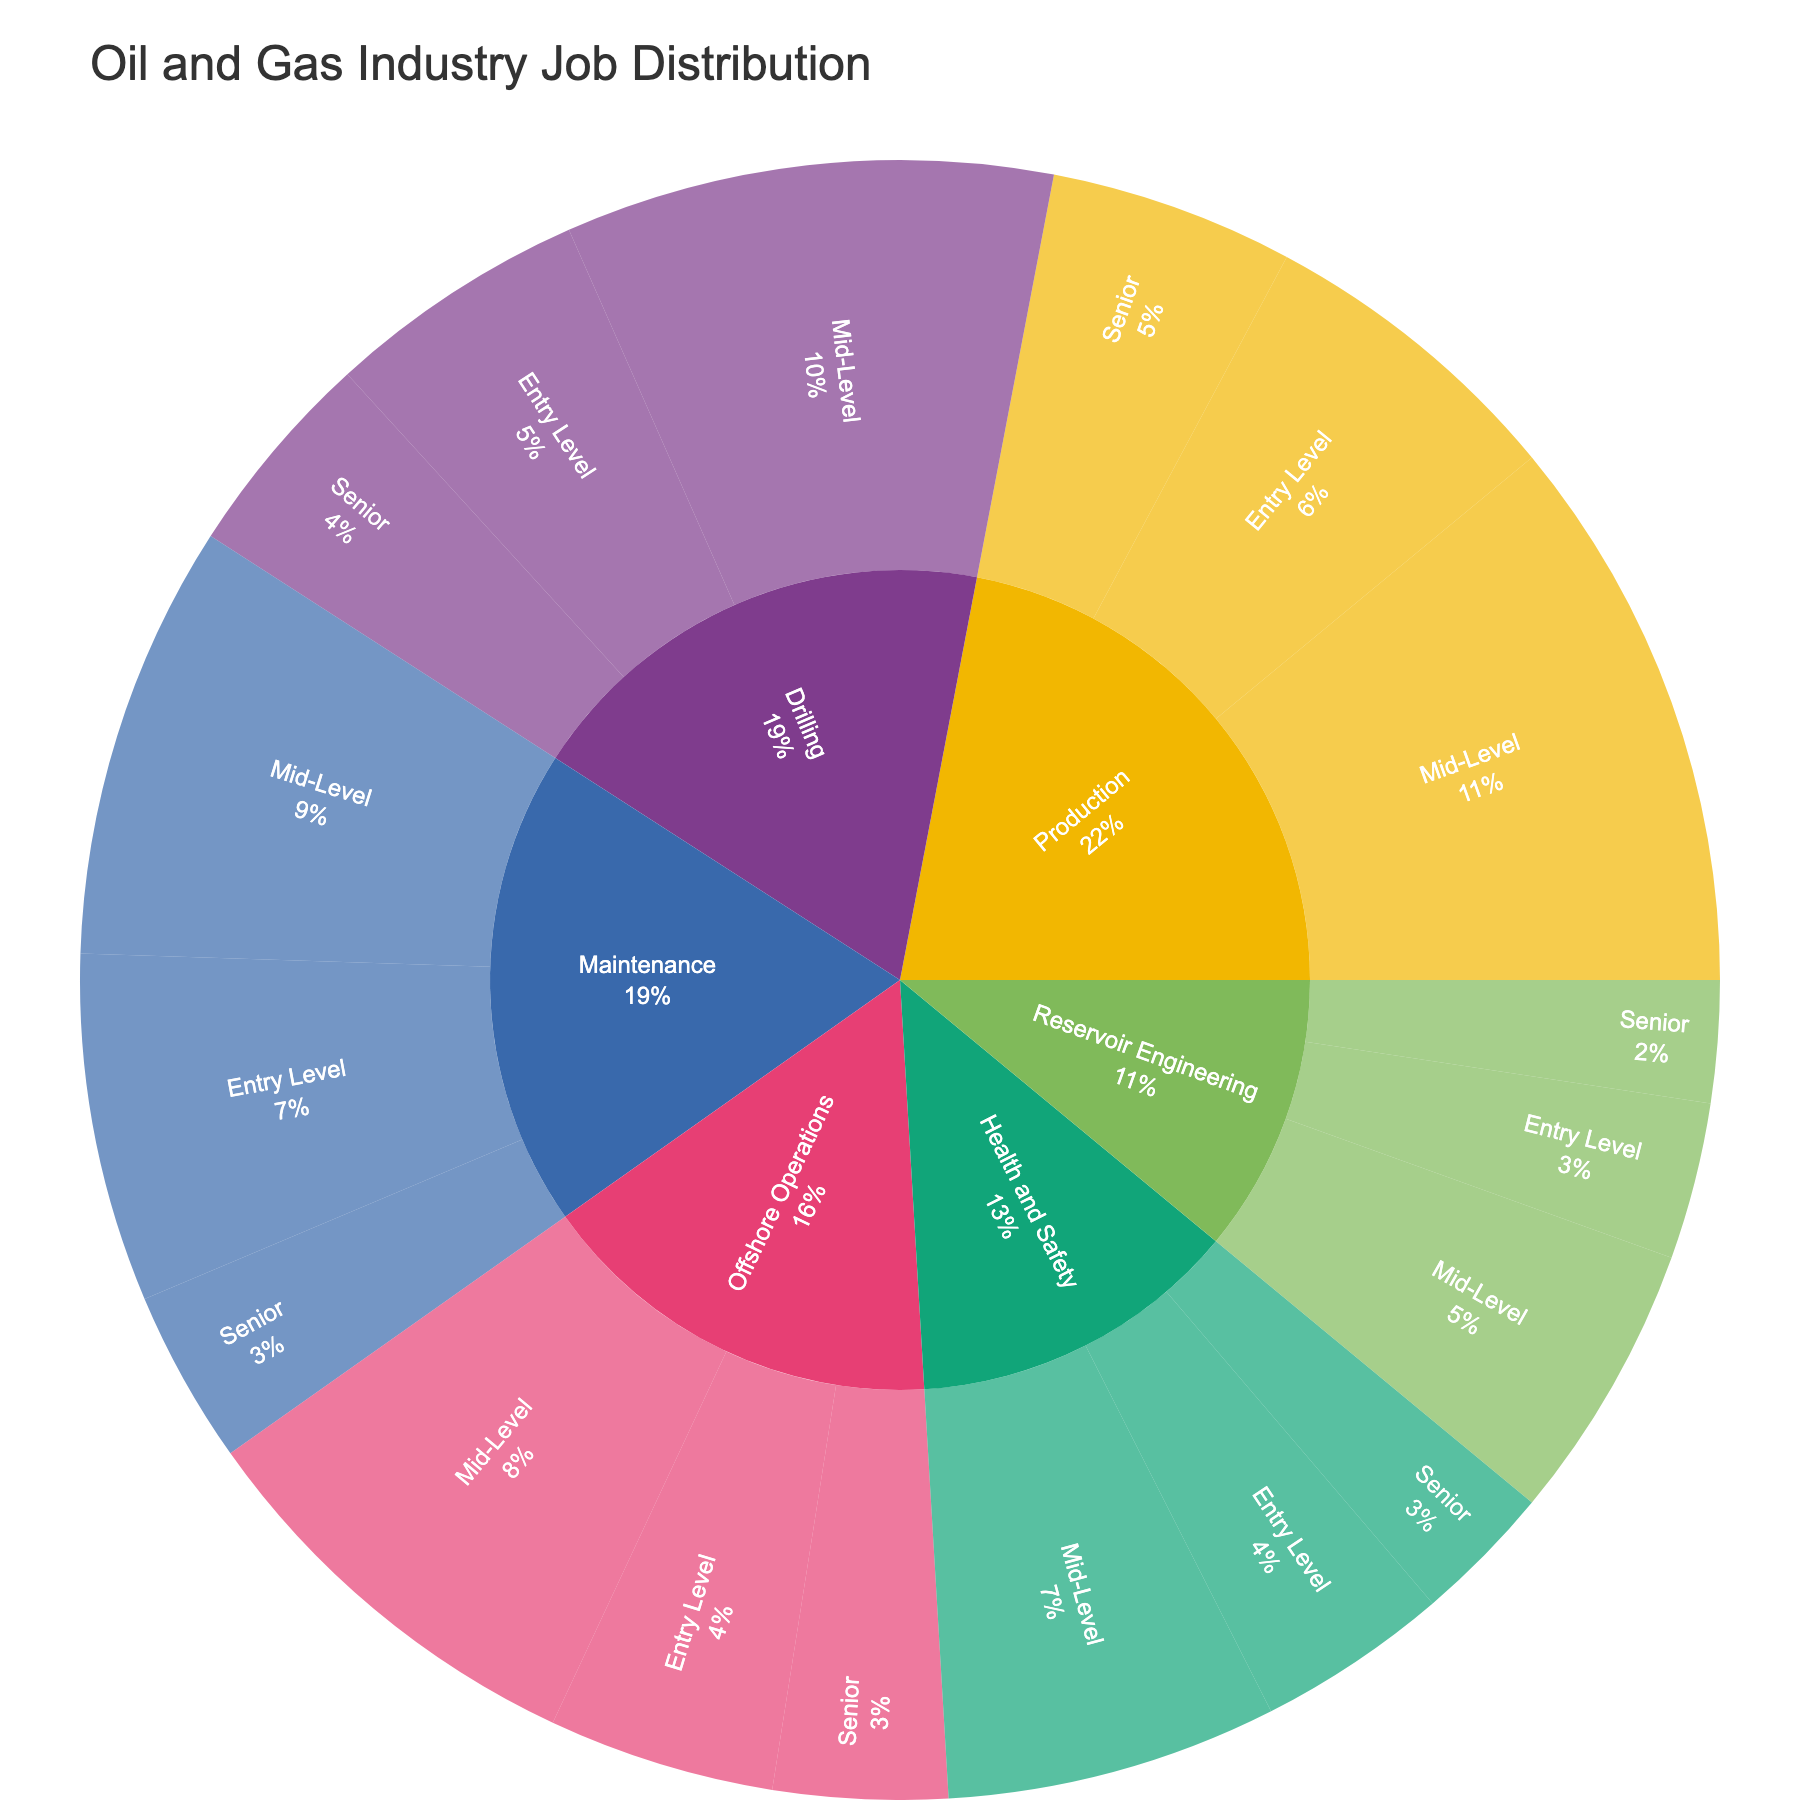How many specializations are represented in the plot? The plot features different specializations as segments in the outer layer. Count these segments to determine the number of distinct specializations.
Answer: 6 Which specialization has the highest total job count? Sum the job counts for all experience levels within each specialization, then compare these sums. Drilling (150 + 280 + 120), Production (180 + 320 + 140), Maintenance (200 + 250 + 100), Reservoir Engineering (90 + 160 + 70), Health and Safety (110 + 190 + 80), Offshore Operations (130 + 240 + 100). Production has the highest total job count.
Answer: Production Compare the number of entry-level jobs in Drilling and Maintenance. Which has more? Look for the counts of entry-level jobs within the Drilling (150) and Maintenance (200) specializations and compare them. Maintenance has more.
Answer: Maintenance What is the percentage of mid-level jobs in Production relative to total mid-level jobs? Calculate the total number of mid-level jobs (280 + 320 + 250 + 160 + 190 + 240) and find the ratio of mid-level jobs in Production (320) to this total. Total mid-level jobs: 1440. (320/1440) * 100 = 22.2%
Answer: 22.2% Which specialization has the least senior-level jobs? Compare the senior-level job counts across all specializations. Drilling (120), Production (140), Maintenance (100), Reservoir Engineering (70), Health and Safety (80), Offshore Operations (100). Reservoir Engineering has the least.
Answer: Reservoir Engineering How does the number of entry-level jobs compare to senior-level jobs in Offshore Operations? Identify the entry-level (130) and senior-level (100) job counts in Offshore Operations and compare them. There are more entry-level jobs than senior-level jobs.
Answer: More entry-level jobs What is the combined total of mid-level and senior-level jobs in Maintenance? Add the mid-level (250) and senior-level (100) job counts in Maintenance. 250 + 100 = 350
Answer: 350 In the specialization with the lowest total job count, what percentage are entry-level? First, sum the job counts in each specialization and find the one with the least total. Reservoir Engineering (90 + 160 + 70 = 320) has the lowest. Calculate the ratio of entry-level jobs in Reservoir Engineering (90) to its total (320). (90/320) * 100 = 28.1%
Answer: 28.1% Which specialization has almost the same number of jobs for mid-level and entry-level experience combined as the total number of jobs in Maintenance? Sum the mid-level and entry-level job counts in other specializations and compare to the total number of jobs in Maintenance (550). For Offshore Operations: (240 + 130 = 370), for Health and Safety: (190 + 110 = 300), for Reservoir Engineering (160 + 90 = 250), for Production (320 + 180 = 500), for Drilling (280 + 150 = 430). None of the specializations match exactly.
Answer: None 